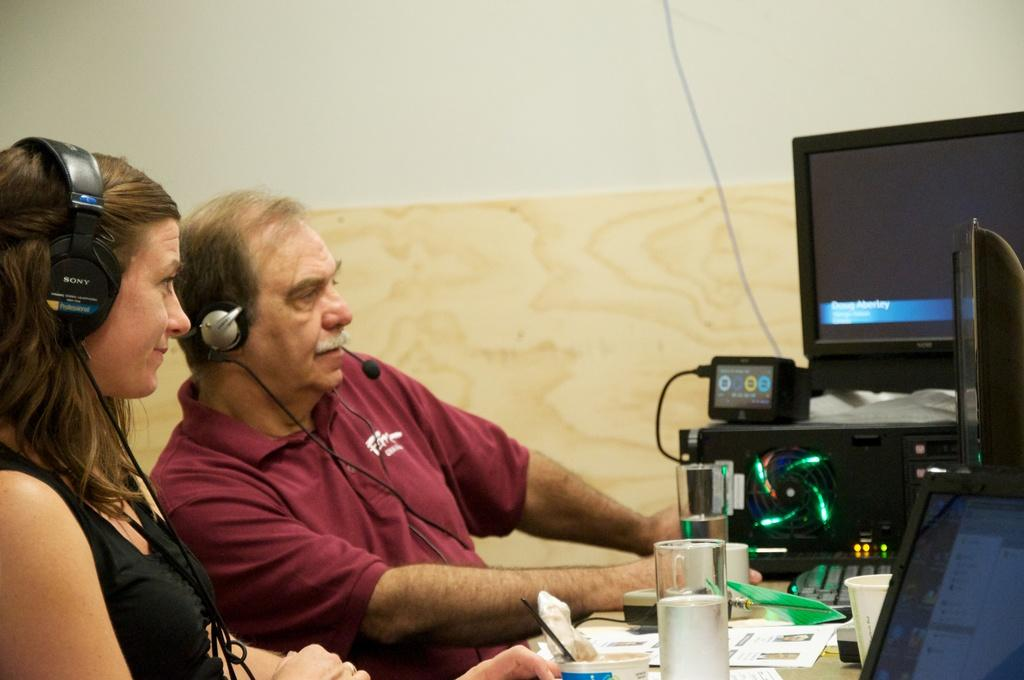How many people are on the left side of the image? There are two persons on the left side of the image. What is located in front of the persons? There is a table in front of the persons. What can be seen on the table? There are many objects on the table. What is visible in the background of the image? There is a wall in the background of the image. How many boys are sitting on the table in the image? There is no mention of boys in the image; it only states that there are two persons on the left side of the image. What type of sponge is being used by the persons in the image? There is no sponge present in the image. 